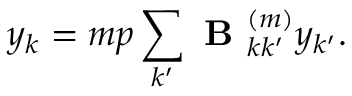<formula> <loc_0><loc_0><loc_500><loc_500>y _ { k } = m p \sum _ { k ^ { \prime } } B _ { k k ^ { \prime } } ^ { ( m ) } y _ { k ^ { \prime } } .</formula> 